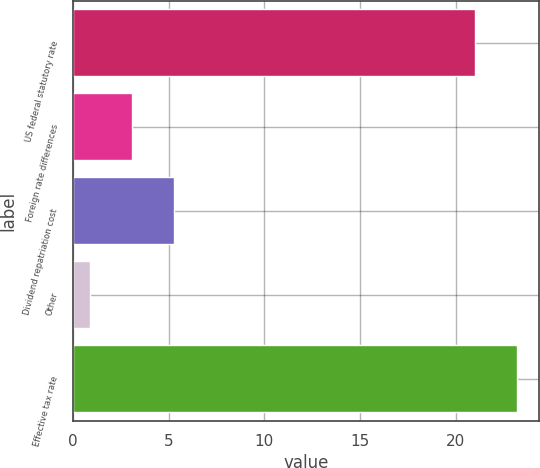Convert chart to OTSL. <chart><loc_0><loc_0><loc_500><loc_500><bar_chart><fcel>US federal statutory rate<fcel>Foreign rate differences<fcel>Dividend repatriation cost<fcel>Other<fcel>Effective tax rate<nl><fcel>21<fcel>3.1<fcel>5.3<fcel>0.9<fcel>23.2<nl></chart> 